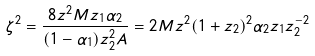Convert formula to latex. <formula><loc_0><loc_0><loc_500><loc_500>\zeta ^ { 2 } = \frac { 8 z ^ { 2 } M z _ { 1 } \alpha _ { 2 } } { ( 1 - \alpha _ { 1 } ) z ^ { 2 } _ { 2 } A } = 2 M z ^ { 2 } ( 1 + z _ { 2 } ) ^ { 2 } \alpha _ { 2 } z _ { 1 } z _ { 2 } ^ { - 2 }</formula> 